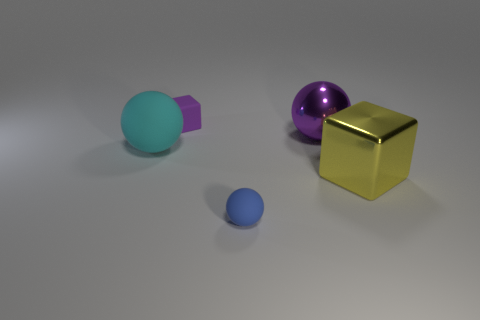How does the lighting in the scene affect the appearance of the different objects? The lighting in this scene creates subtle shadows and highlights on the objects, enhancing their three-dimensional form. The gold cube reflects the light strongly, suggesting it has a metallic finish, while the spheres have softer reflections indicative of a less shiny, perhaps plastic or rubber, finish. 